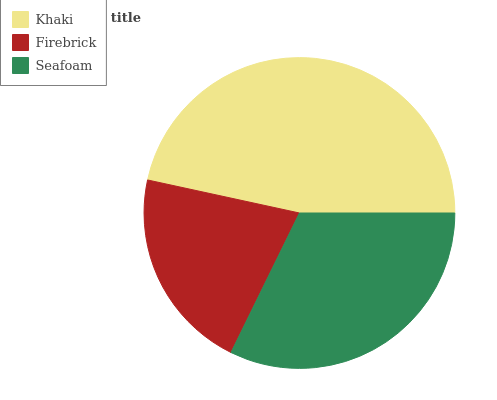Is Firebrick the minimum?
Answer yes or no. Yes. Is Khaki the maximum?
Answer yes or no. Yes. Is Seafoam the minimum?
Answer yes or no. No. Is Seafoam the maximum?
Answer yes or no. No. Is Seafoam greater than Firebrick?
Answer yes or no. Yes. Is Firebrick less than Seafoam?
Answer yes or no. Yes. Is Firebrick greater than Seafoam?
Answer yes or no. No. Is Seafoam less than Firebrick?
Answer yes or no. No. Is Seafoam the high median?
Answer yes or no. Yes. Is Seafoam the low median?
Answer yes or no. Yes. Is Firebrick the high median?
Answer yes or no. No. Is Khaki the low median?
Answer yes or no. No. 